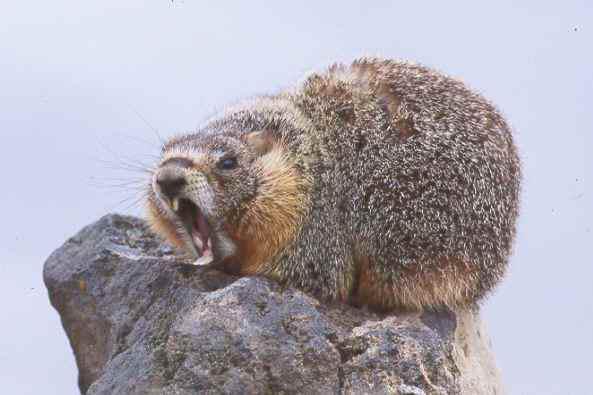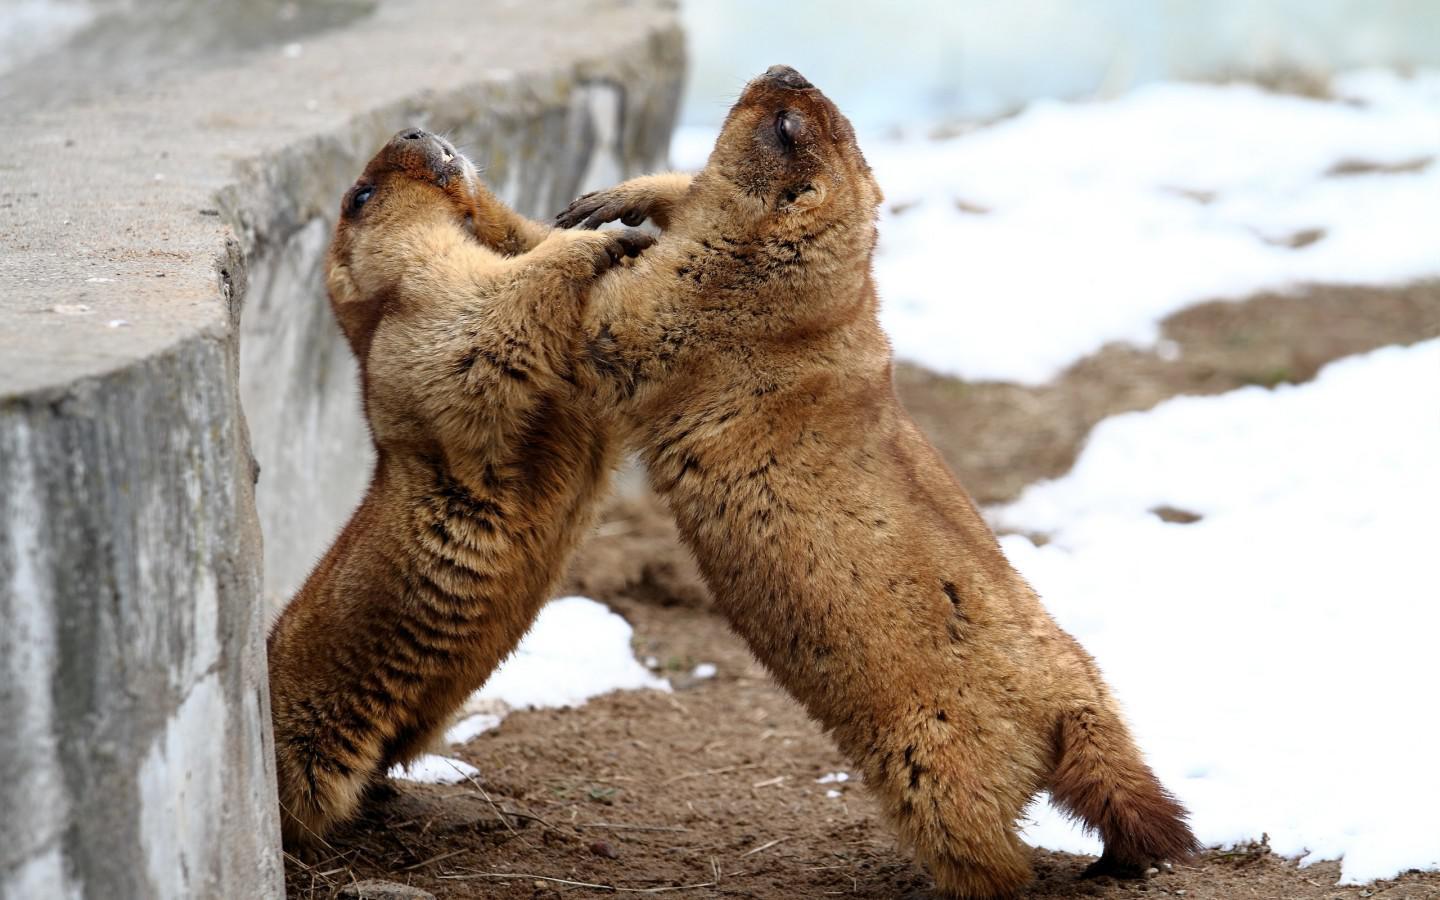The first image is the image on the left, the second image is the image on the right. Assess this claim about the two images: "The left image contains exactly one rodent in the snow.". Correct or not? Answer yes or no. No. The first image is the image on the left, the second image is the image on the right. For the images displayed, is the sentence "An image shows a single close-mouthed marmot poking its head up out of the snow." factually correct? Answer yes or no. No. 